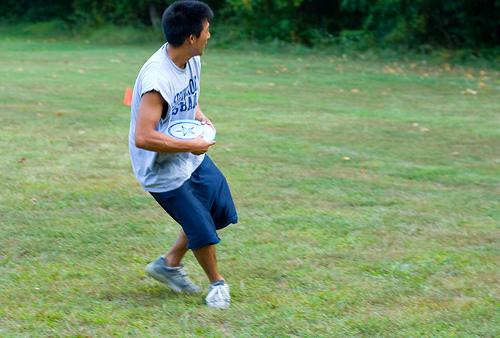Mention five features you observe in the image related to the man, his clothing, and his accessories. Black hair, grey shirt, blue shorts, white frisbee with a star on it, and shoes. What is the primary action being performed by the man in the image? Mention any specific details about his clothing and accessories. The man is getting ready to throw a frisbee. He is wearing a grey shirt, blue shorts, and shoes. The frisbee has a star on top. Provide a brief description of the man in the image and his action. A man with black hair, wearing a grey shirt, blue shorts, and shoes, is holding a frisbee and appears ready to throw it. Name three activities that the man seems to be doing, as well as any related objects he is using or interacting with. Getting ready to throw a frisbee, holding a white frisbee with a star on top, and standing in the grass. Identify the man's sport and any visible objects or details related to the sport. The man is playing frisbee, and the visible objects related to the sport include a white frisbee with a star, a healthy green field, and a small orange cone. What type of sport appears to be taking place in the image? Describe the appearance and features of the object used in the sport. Frisbee appears to be the sport taking place in the image. The frisbee is white in color with a blue and white design, featuring a star on top. Explain the scene in the image focusing on the sports activity, and the man's attire. In the image, a man in athletic clothing consisting of a grey shirt and blue shorts is engaging in a popular summer activity, playing frisbee on a green field. In the image, what game is the man playing and what is the most noticeable feature of the object he is holding? The man is playing frisbee, and the most noticeable feature of the frisbee is a star on it. Describe the predominant colors and objects in the image. Predominant colors are green (grass), blue (shorts), and grey (shirt). Objects include a man, a frisbee, and the surrounding environment like grass and leaves on the ground. Describe the man's stance while interacting with the object in the image, and mention the type and distinct details of the object. The man's knees are bent, and he is holding a white frisbee that has a star on top. 